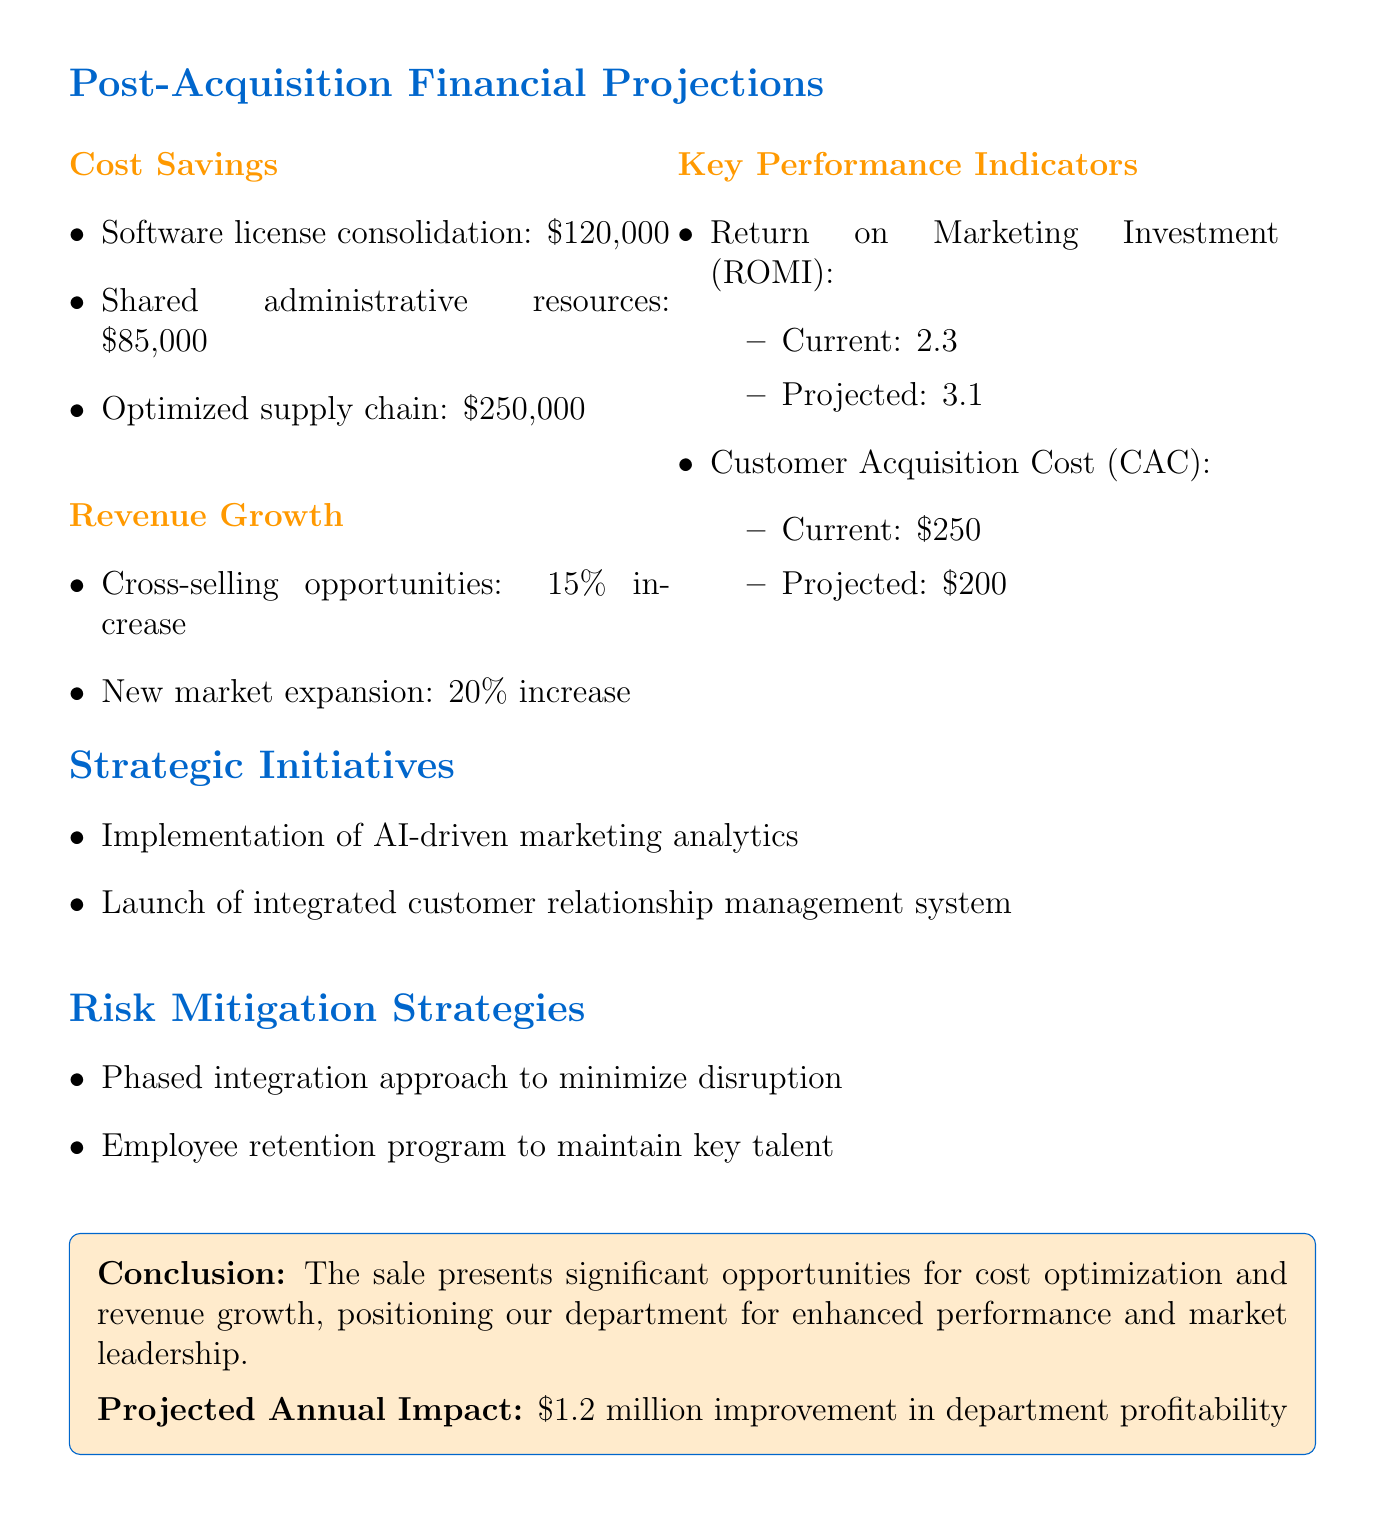What is the annual savings from software license consolidation? This information is found in the cost savings section, specifically stating the amount for software license consolidation.
Answer: $120,000 What is the projected increase from new market expansion? This is located in the revenue growth section where the projected increase is specified.
Answer: 20% What is the current Customer Acquisition Cost (CAC)? The current CAC is detailed in the key performance indicators section.
Answer: $250 What is the projected Return on Marketing Investment (ROMI)? The projected ROMI is provided in the key performance indicators section.
Answer: 3.1 What is the total projected annual impact on department profitability? This figure is found in the conclusion of the document summarizing the expected financial impact.
Answer: $1.2 million What strategic initiative involves AI? This is mentioned in the strategic initiatives section, referencing a specific technological advancement.
Answer: Implementation of AI-driven marketing analytics What risk mitigation strategy focuses on employee retention? This is specified in the risk mitigation strategies section regarding maintaining talent.
Answer: Employee retention program What is the annual savings from an optimized supply chain? This amount is listed in the cost savings section as part of the total savings identified.
Answer: $250,000 